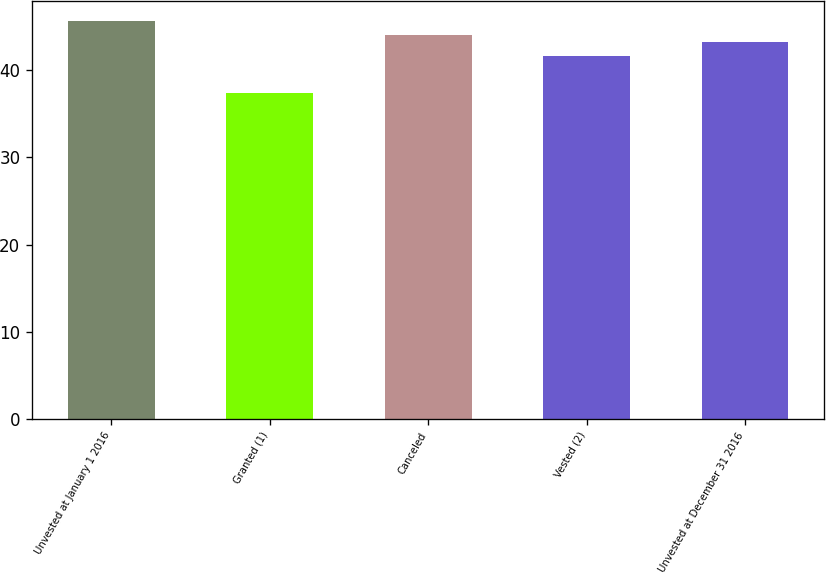<chart> <loc_0><loc_0><loc_500><loc_500><bar_chart><fcel>Unvested at January 1 2016<fcel>Granted (1)<fcel>Canceled<fcel>Vested (2)<fcel>Unvested at December 31 2016<nl><fcel>45.73<fcel>37.35<fcel>44.08<fcel>41.63<fcel>43.24<nl></chart> 